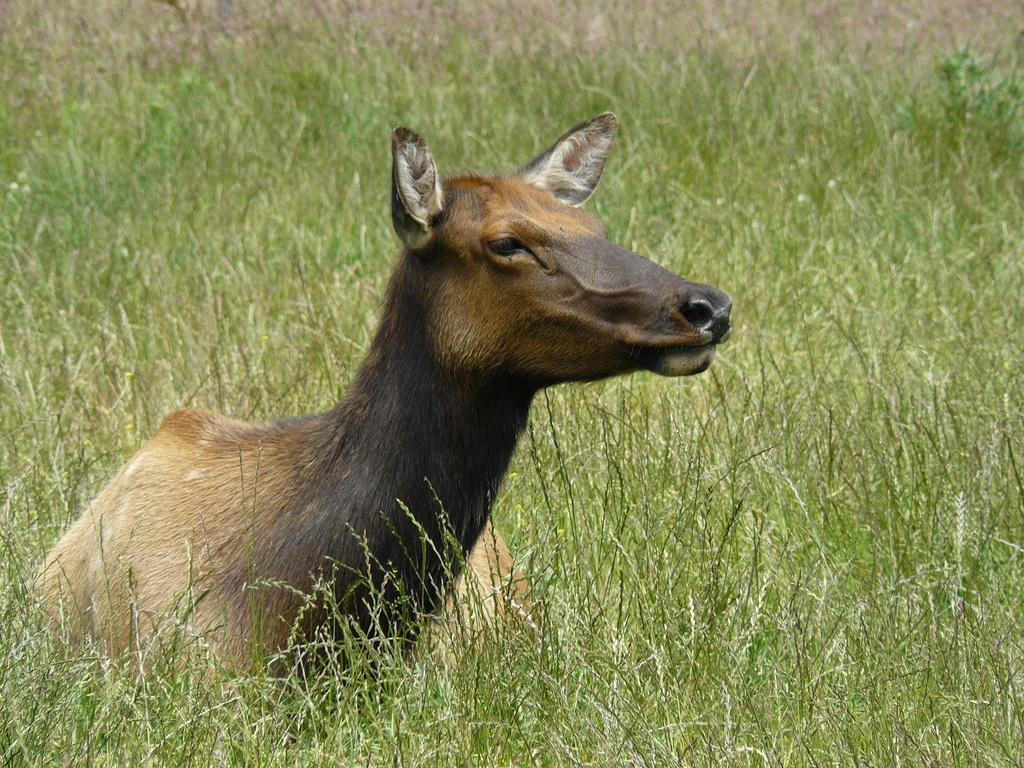What is the main subject in the center of the image? There is an animal in the center of the image. What is the animal doing in the image? The animal is laying on the plants. What type of vegetation can be seen in the background of the image? There is grass and plants in the background of the image. What word can be heard being spoken by the animal in the image? There is no indication in the image that the animal is speaking or making any noise, so it cannot be determined from the picture. 